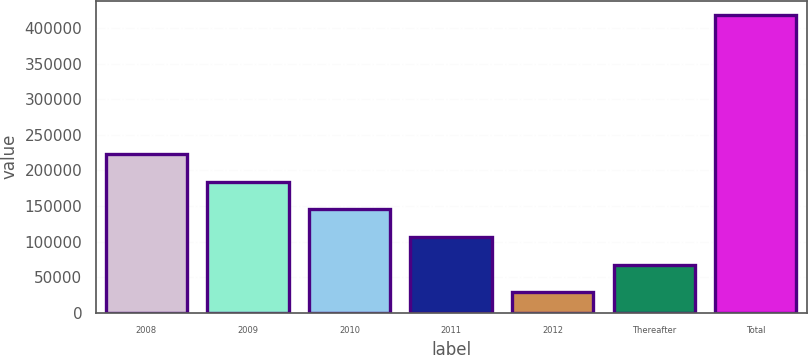Convert chart. <chart><loc_0><loc_0><loc_500><loc_500><bar_chart><fcel>2008<fcel>2009<fcel>2010<fcel>2011<fcel>2012<fcel>Thereafter<fcel>Total<nl><fcel>223282<fcel>184375<fcel>145468<fcel>106562<fcel>28749<fcel>67655.5<fcel>417814<nl></chart> 